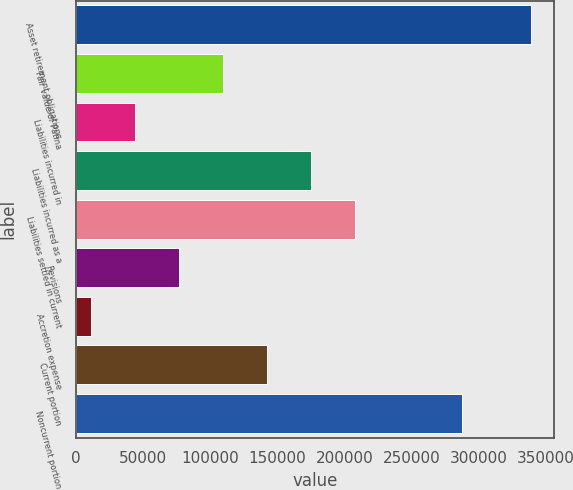<chart> <loc_0><loc_0><loc_500><loc_500><bar_chart><fcel>Asset retirement obligations<fcel>Fair value of Patina<fcel>Liabilities incurred in<fcel>Liabilities incurred as a<fcel>Liabilities settled in current<fcel>Revisions<fcel>Accretion expense<fcel>Current portion<fcel>Noncurrent portion<nl><fcel>338871<fcel>109511<fcel>43979.7<fcel>175042<fcel>207808<fcel>76745.4<fcel>11214<fcel>142277<fcel>287749<nl></chart> 